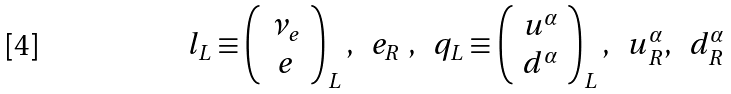Convert formula to latex. <formula><loc_0><loc_0><loc_500><loc_500>l _ { L } \equiv \left ( \begin{array} { c } \nu _ { e } \\ e \end{array} \right ) _ { L } , \ \ e _ { R } \ , \ \ q _ { L } \equiv \left ( \begin{array} { c } u ^ { \alpha } \\ d ^ { \alpha } \end{array} \right ) _ { L } , \ \ u _ { R } ^ { \alpha } , \ \ d _ { R } ^ { \alpha }</formula> 